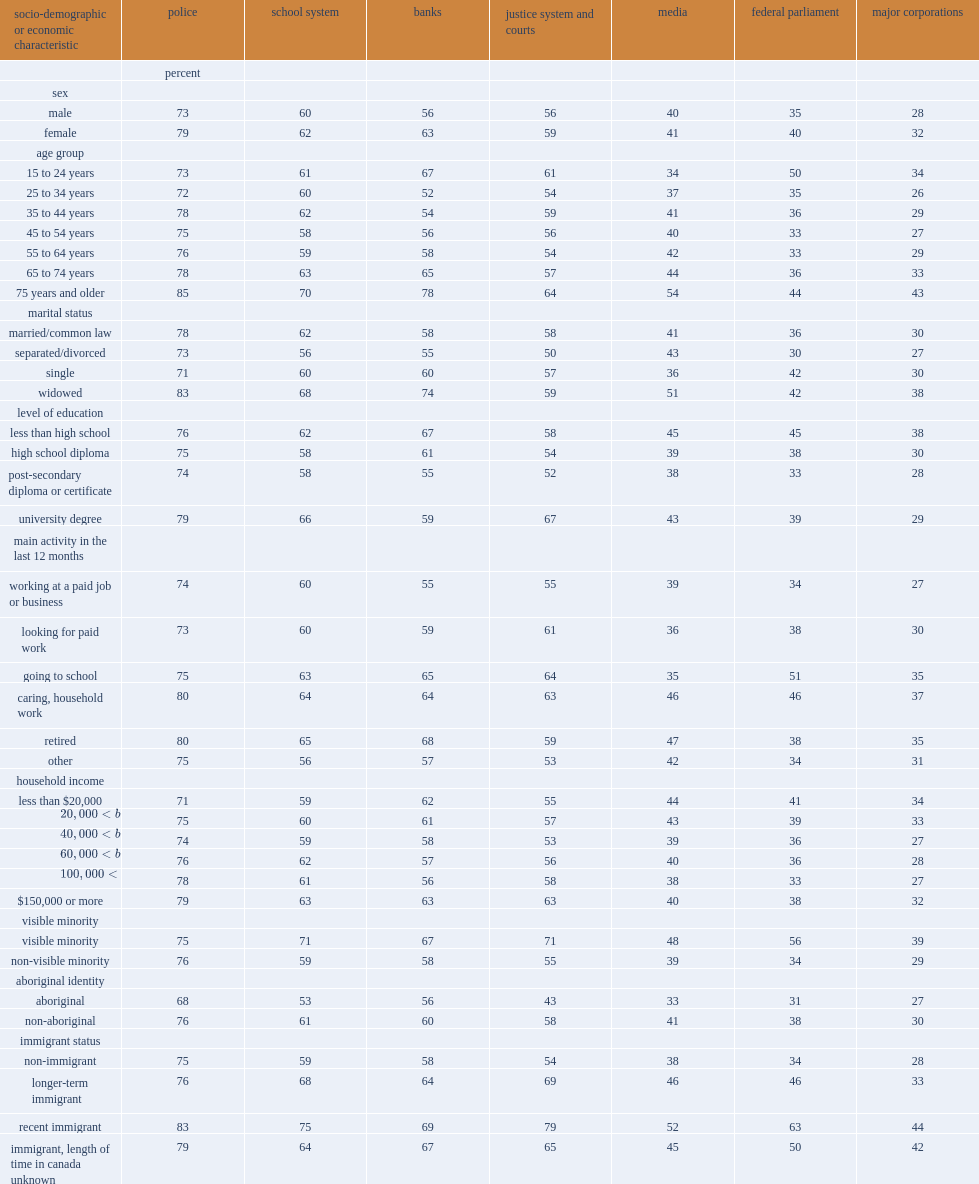For the justice system and courts, how many percent of the proportion of aboriginal people who stated they had confidence was lower than for non-aboriginal people? 15. 